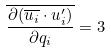Convert formula to latex. <formula><loc_0><loc_0><loc_500><loc_500>\overline { \frac { \partial ( \overline { u _ { i } } \cdot u _ { i } ^ { \prime } ) } { \partial q _ { i } } } = 3</formula> 